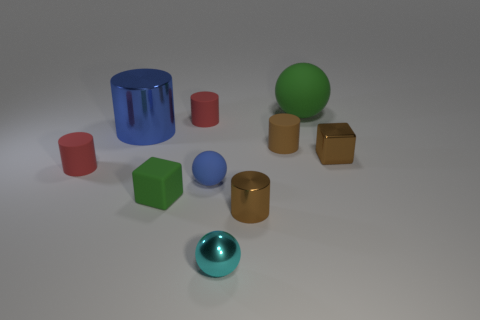Subtract all brown metallic cylinders. How many cylinders are left? 4 Subtract all blue cylinders. How many cylinders are left? 4 Subtract all purple cylinders. Subtract all green blocks. How many cylinders are left? 5 Subtract all blocks. How many objects are left? 8 Subtract 0 blue blocks. How many objects are left? 10 Subtract all tiny green blocks. Subtract all big cylinders. How many objects are left? 8 Add 5 tiny rubber balls. How many tiny rubber balls are left? 6 Add 1 blue rubber spheres. How many blue rubber spheres exist? 2 